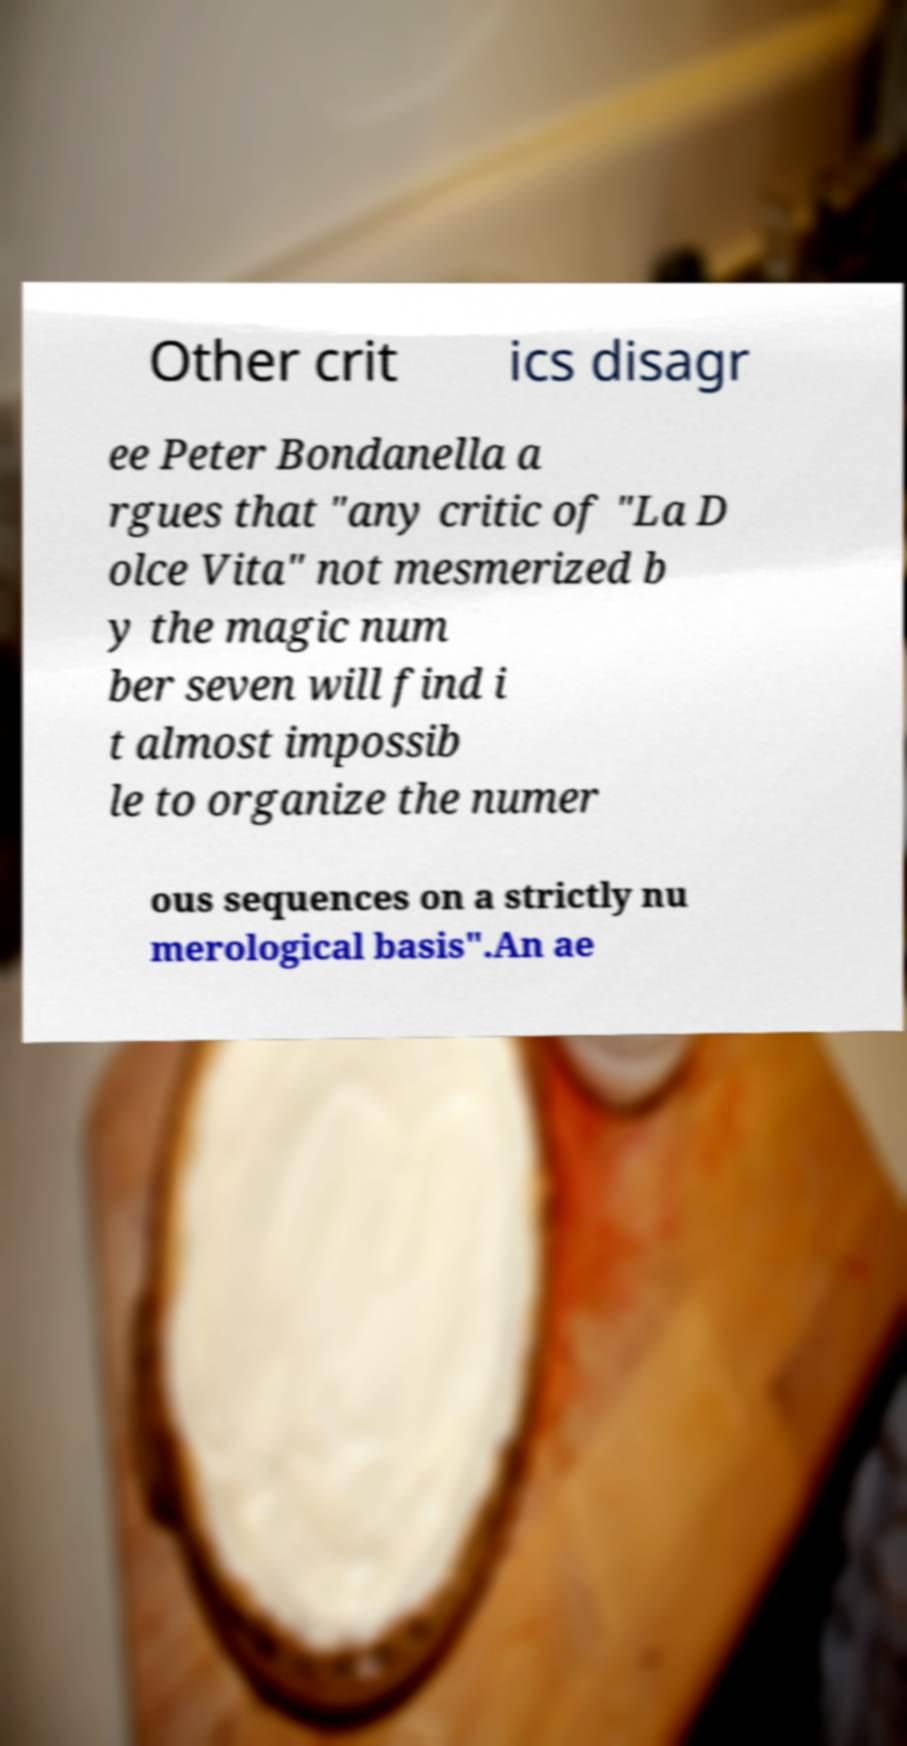Can you read and provide the text displayed in the image?This photo seems to have some interesting text. Can you extract and type it out for me? Other crit ics disagr ee Peter Bondanella a rgues that "any critic of "La D olce Vita" not mesmerized b y the magic num ber seven will find i t almost impossib le to organize the numer ous sequences on a strictly nu merological basis".An ae 